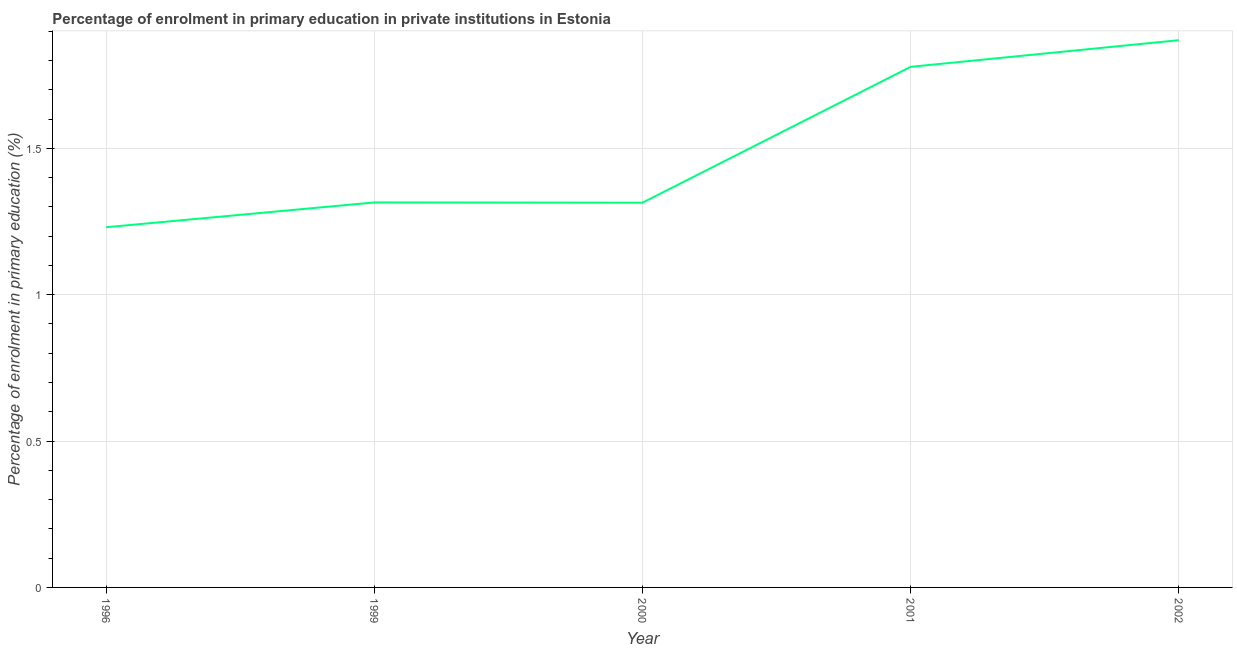What is the enrolment percentage in primary education in 2002?
Provide a short and direct response. 1.87. Across all years, what is the maximum enrolment percentage in primary education?
Offer a terse response. 1.87. Across all years, what is the minimum enrolment percentage in primary education?
Your answer should be very brief. 1.23. In which year was the enrolment percentage in primary education maximum?
Offer a terse response. 2002. What is the sum of the enrolment percentage in primary education?
Offer a terse response. 7.51. What is the difference between the enrolment percentage in primary education in 1996 and 1999?
Your response must be concise. -0.08. What is the average enrolment percentage in primary education per year?
Your response must be concise. 1.5. What is the median enrolment percentage in primary education?
Keep it short and to the point. 1.32. Do a majority of the years between 2001 and 1996 (inclusive) have enrolment percentage in primary education greater than 1.8 %?
Your answer should be compact. Yes. What is the ratio of the enrolment percentage in primary education in 1996 to that in 2002?
Give a very brief answer. 0.66. Is the enrolment percentage in primary education in 1999 less than that in 2000?
Provide a short and direct response. No. What is the difference between the highest and the second highest enrolment percentage in primary education?
Give a very brief answer. 0.09. Is the sum of the enrolment percentage in primary education in 2000 and 2001 greater than the maximum enrolment percentage in primary education across all years?
Your answer should be very brief. Yes. What is the difference between the highest and the lowest enrolment percentage in primary education?
Your response must be concise. 0.64. How many years are there in the graph?
Keep it short and to the point. 5. What is the difference between two consecutive major ticks on the Y-axis?
Keep it short and to the point. 0.5. Are the values on the major ticks of Y-axis written in scientific E-notation?
Your answer should be compact. No. Does the graph contain any zero values?
Your response must be concise. No. Does the graph contain grids?
Ensure brevity in your answer.  Yes. What is the title of the graph?
Give a very brief answer. Percentage of enrolment in primary education in private institutions in Estonia. What is the label or title of the Y-axis?
Ensure brevity in your answer.  Percentage of enrolment in primary education (%). What is the Percentage of enrolment in primary education (%) of 1996?
Keep it short and to the point. 1.23. What is the Percentage of enrolment in primary education (%) of 1999?
Offer a very short reply. 1.32. What is the Percentage of enrolment in primary education (%) of 2000?
Your answer should be compact. 1.31. What is the Percentage of enrolment in primary education (%) of 2001?
Provide a short and direct response. 1.78. What is the Percentage of enrolment in primary education (%) in 2002?
Your answer should be compact. 1.87. What is the difference between the Percentage of enrolment in primary education (%) in 1996 and 1999?
Your response must be concise. -0.08. What is the difference between the Percentage of enrolment in primary education (%) in 1996 and 2000?
Your answer should be compact. -0.08. What is the difference between the Percentage of enrolment in primary education (%) in 1996 and 2001?
Give a very brief answer. -0.55. What is the difference between the Percentage of enrolment in primary education (%) in 1996 and 2002?
Provide a short and direct response. -0.64. What is the difference between the Percentage of enrolment in primary education (%) in 1999 and 2000?
Ensure brevity in your answer.  0. What is the difference between the Percentage of enrolment in primary education (%) in 1999 and 2001?
Make the answer very short. -0.46. What is the difference between the Percentage of enrolment in primary education (%) in 1999 and 2002?
Your answer should be very brief. -0.55. What is the difference between the Percentage of enrolment in primary education (%) in 2000 and 2001?
Your answer should be very brief. -0.46. What is the difference between the Percentage of enrolment in primary education (%) in 2000 and 2002?
Offer a terse response. -0.56. What is the difference between the Percentage of enrolment in primary education (%) in 2001 and 2002?
Provide a succinct answer. -0.09. What is the ratio of the Percentage of enrolment in primary education (%) in 1996 to that in 1999?
Offer a very short reply. 0.94. What is the ratio of the Percentage of enrolment in primary education (%) in 1996 to that in 2000?
Offer a terse response. 0.94. What is the ratio of the Percentage of enrolment in primary education (%) in 1996 to that in 2001?
Offer a very short reply. 0.69. What is the ratio of the Percentage of enrolment in primary education (%) in 1996 to that in 2002?
Keep it short and to the point. 0.66. What is the ratio of the Percentage of enrolment in primary education (%) in 1999 to that in 2000?
Your answer should be compact. 1. What is the ratio of the Percentage of enrolment in primary education (%) in 1999 to that in 2001?
Offer a very short reply. 0.74. What is the ratio of the Percentage of enrolment in primary education (%) in 1999 to that in 2002?
Offer a terse response. 0.7. What is the ratio of the Percentage of enrolment in primary education (%) in 2000 to that in 2001?
Your response must be concise. 0.74. What is the ratio of the Percentage of enrolment in primary education (%) in 2000 to that in 2002?
Ensure brevity in your answer.  0.7. What is the ratio of the Percentage of enrolment in primary education (%) in 2001 to that in 2002?
Provide a short and direct response. 0.95. 